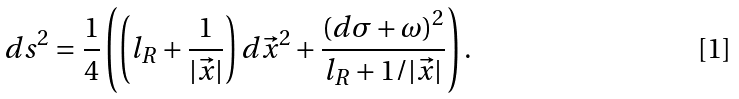<formula> <loc_0><loc_0><loc_500><loc_500>d s ^ { 2 } = \frac { 1 } { 4 } \left ( \left ( l _ { R } + \frac { 1 } { | \vec { x } | } \right ) d \vec { x } ^ { 2 } + \frac { ( d \sigma + \omega ) ^ { 2 } } { l _ { R } + 1 / | \vec { x } | } \right ) .</formula> 